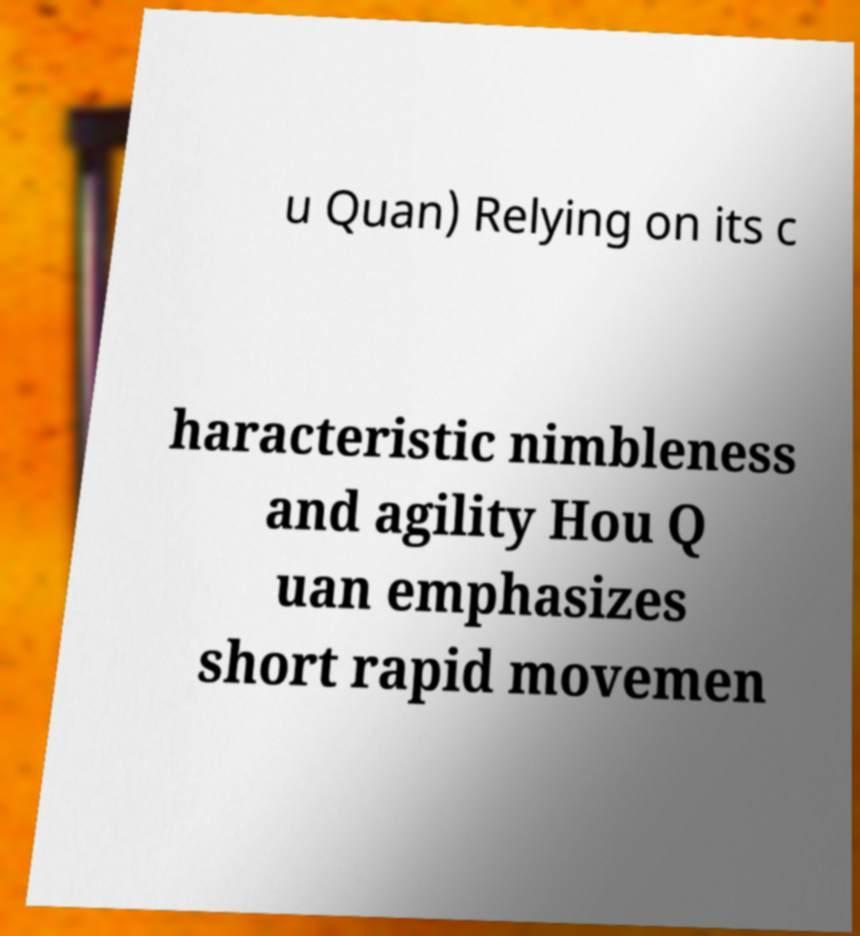Can you accurately transcribe the text from the provided image for me? u Quan) Relying on its c haracteristic nimbleness and agility Hou Q uan emphasizes short rapid movemen 